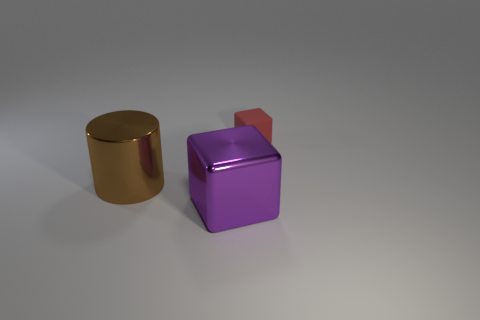Add 1 big shiny cylinders. How many objects exist? 4 Subtract 1 cylinders. How many cylinders are left? 0 Subtract all blue spheres. How many cyan cubes are left? 0 Subtract all metallic things. Subtract all small red rubber cubes. How many objects are left? 0 Add 1 metal cylinders. How many metal cylinders are left? 2 Add 1 brown shiny things. How many brown shiny things exist? 2 Subtract all purple blocks. How many blocks are left? 1 Subtract 0 yellow cylinders. How many objects are left? 3 Subtract all cubes. How many objects are left? 1 Subtract all blue blocks. Subtract all green spheres. How many blocks are left? 2 